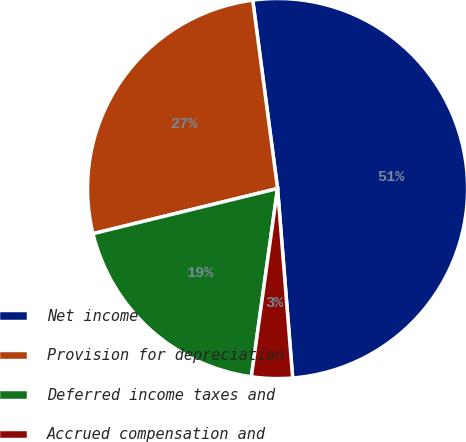Convert chart. <chart><loc_0><loc_0><loc_500><loc_500><pie_chart><fcel>Net income<fcel>Provision for depreciation<fcel>Deferred income taxes and<fcel>Accrued compensation and<nl><fcel>50.82%<fcel>26.73%<fcel>18.98%<fcel>3.47%<nl></chart> 